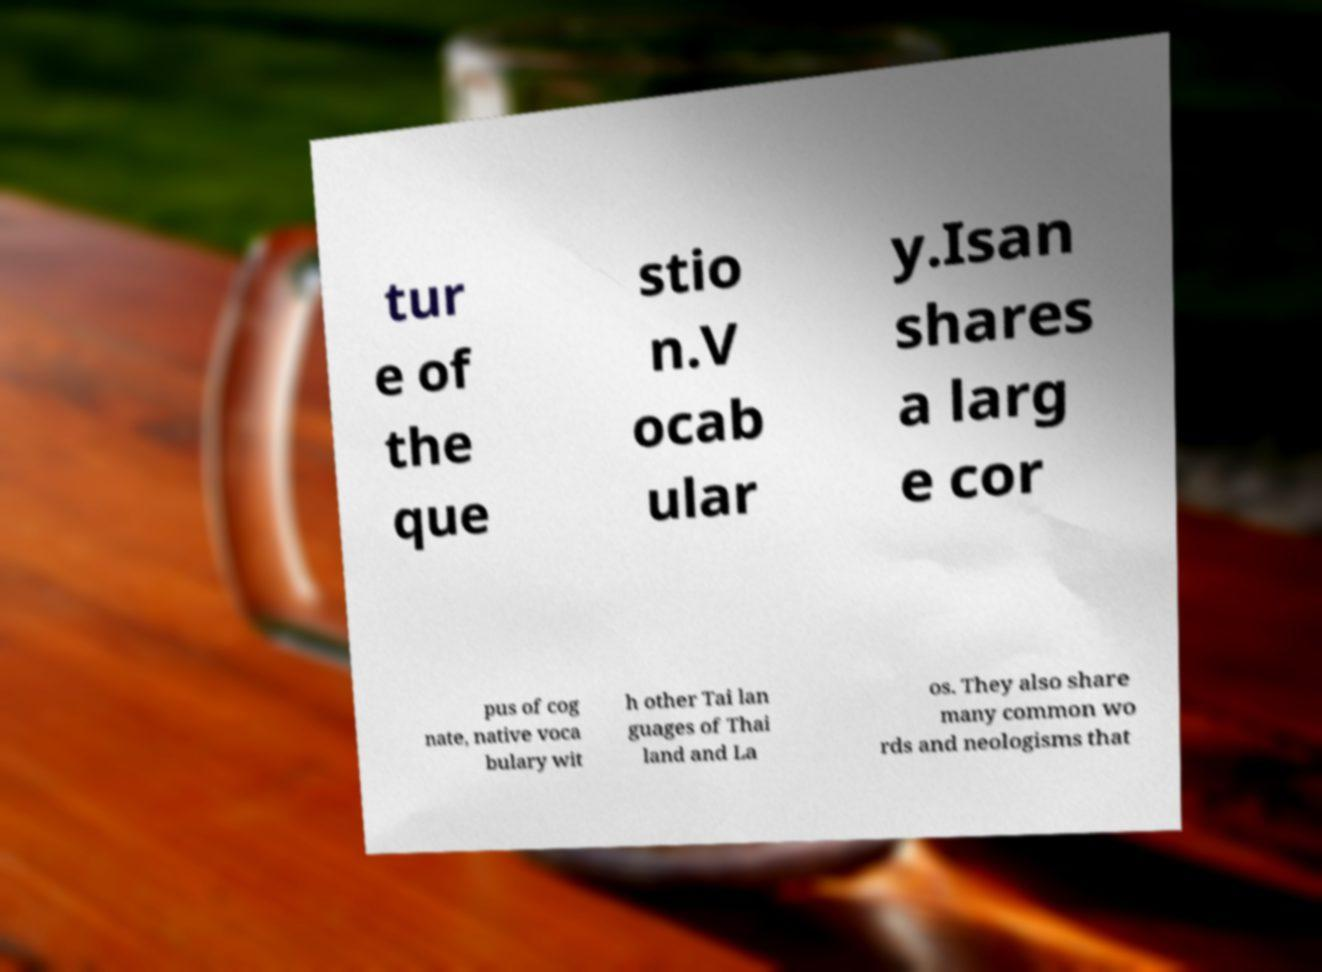Please identify and transcribe the text found in this image. tur e of the que stio n.V ocab ular y.Isan shares a larg e cor pus of cog nate, native voca bulary wit h other Tai lan guages of Thai land and La os. They also share many common wo rds and neologisms that 